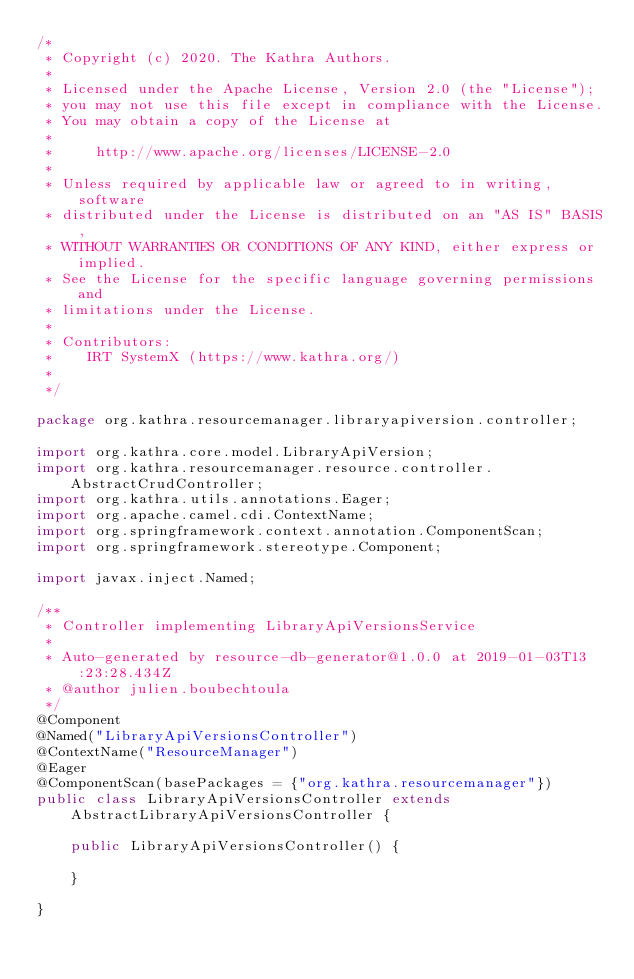Convert code to text. <code><loc_0><loc_0><loc_500><loc_500><_Java_>/*
 * Copyright (c) 2020. The Kathra Authors.
 *
 * Licensed under the Apache License, Version 2.0 (the "License");
 * you may not use this file except in compliance with the License.
 * You may obtain a copy of the License at
 *
 *     http://www.apache.org/licenses/LICENSE-2.0
 *
 * Unless required by applicable law or agreed to in writing, software
 * distributed under the License is distributed on an "AS IS" BASIS,
 * WITHOUT WARRANTIES OR CONDITIONS OF ANY KIND, either express or implied.
 * See the License for the specific language governing permissions and
 * limitations under the License.
 *
 * Contributors:
 *    IRT SystemX (https://www.kathra.org/)
 *
 */

package org.kathra.resourcemanager.libraryapiversion.controller;

import org.kathra.core.model.LibraryApiVersion;
import org.kathra.resourcemanager.resource.controller.AbstractCrudController;
import org.kathra.utils.annotations.Eager;
import org.apache.camel.cdi.ContextName;
import org.springframework.context.annotation.ComponentScan;
import org.springframework.stereotype.Component;

import javax.inject.Named;

/**
 * Controller implementing LibraryApiVersionsService
 *
 * Auto-generated by resource-db-generator@1.0.0 at 2019-01-03T13:23:28.434Z
 * @author julien.boubechtoula
 */
@Component
@Named("LibraryApiVersionsController")
@ContextName("ResourceManager")
@Eager
@ComponentScan(basePackages = {"org.kathra.resourcemanager"})
public class LibraryApiVersionsController extends AbstractLibraryApiVersionsController {

    public LibraryApiVersionsController() {

    }

}
</code> 